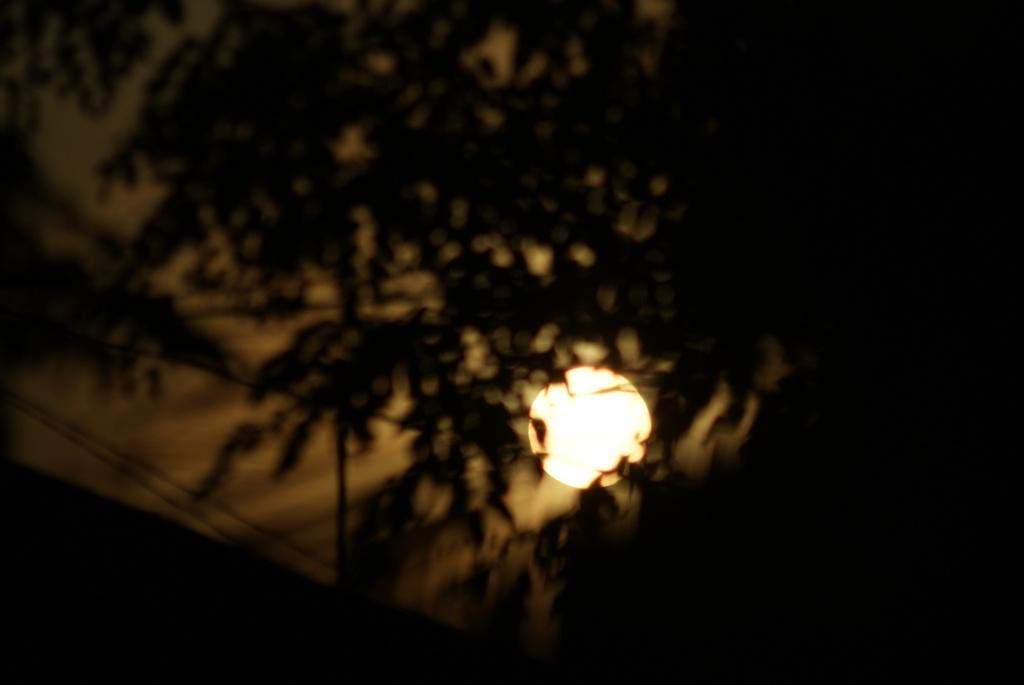What is the overall lighting condition of the image? The image is dark. What type of natural element can be seen in the image? There is a tree in the image. What celestial body is visible in the image? There is a moon visible in the image. Where is the nest located in the image? There is no nest present in the image. Can you describe the mom's expression in the image? There is no mom present in the image. 